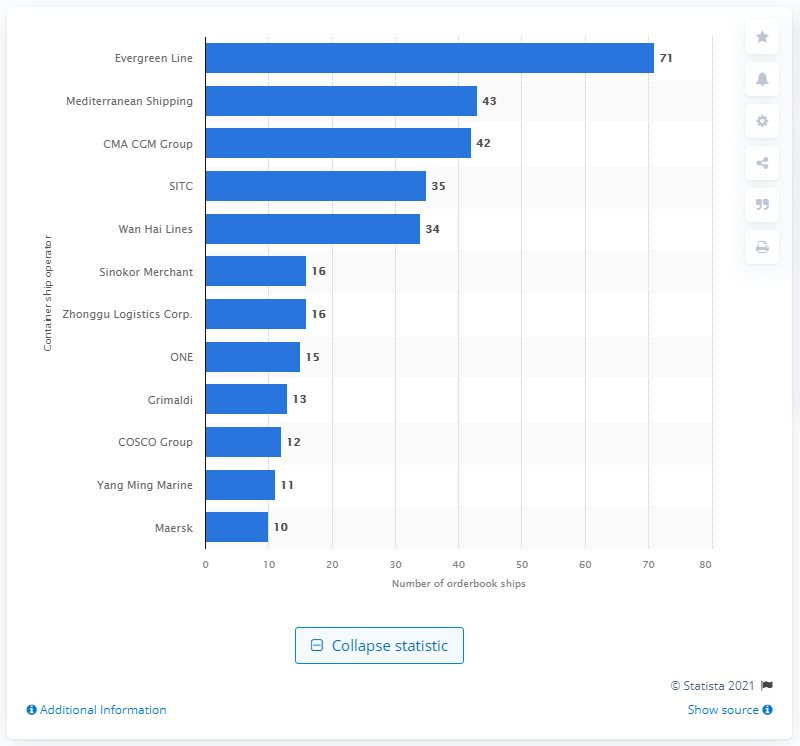What shipping company is shown to have the highest number of ships in their order book? The shipping company with the highest number of ships in their order book, as shown in the image, is the Evergreen Line, which has 71 ships. 